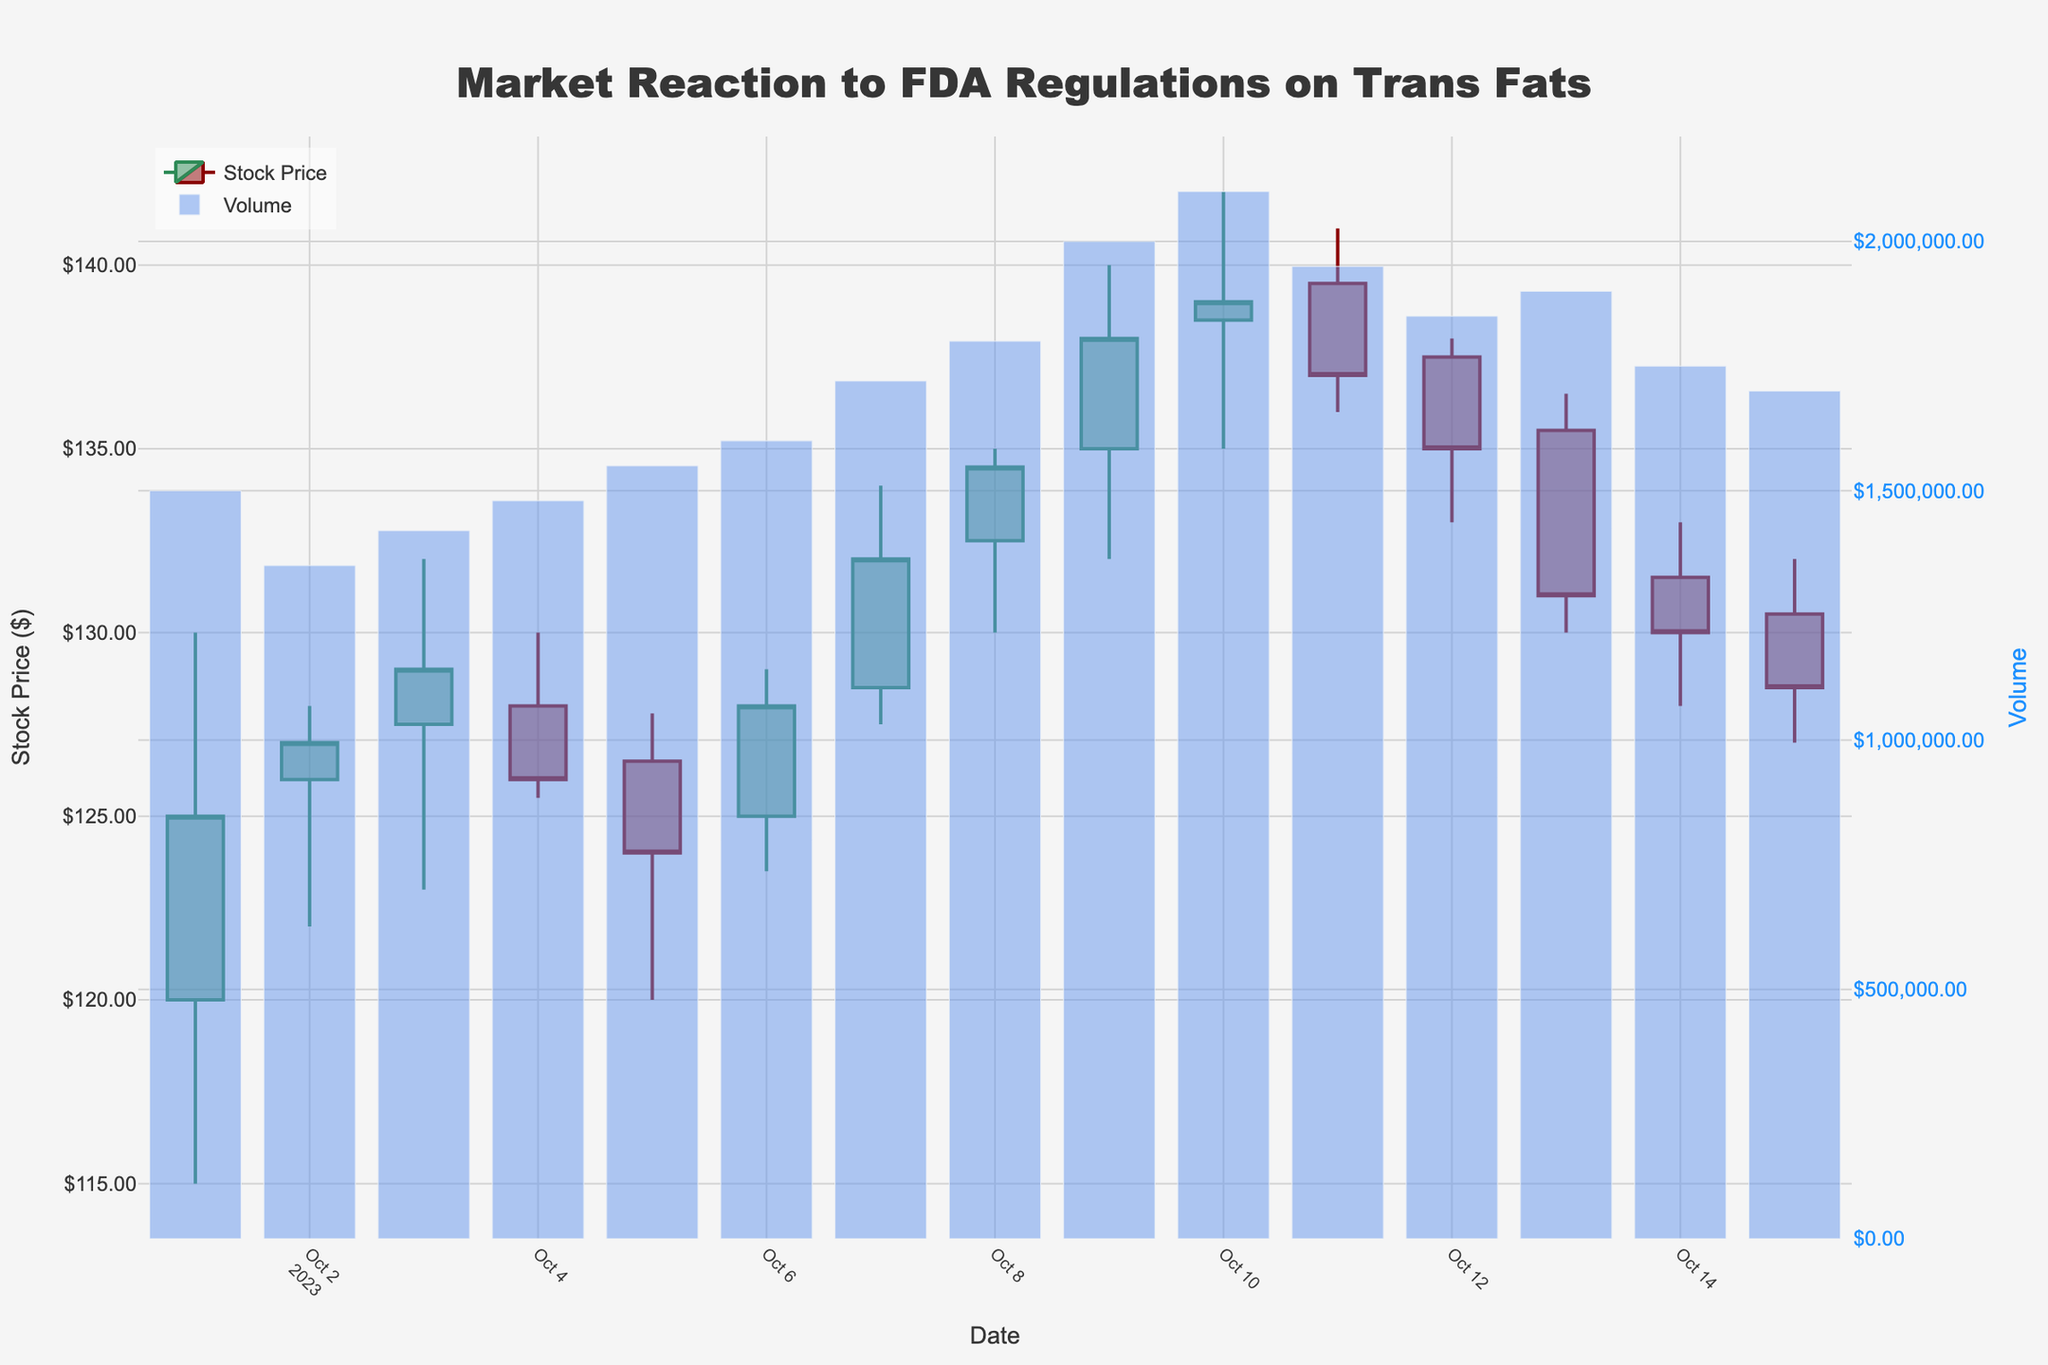What is the highest stock price during the period shown in the figure? The highest stock price is found by looking at the highest points on the candlestick wicks. These wicks represent the 'High' price for each day. The highest price is observed on October 10, 2023, when the price reached $142.00.
Answer: $142.00 What was the closing price on October 1, 2023? To find the closing price on a specific date, look at the bottom of the body of the candlestick for that date. On October 1, 2023, the closing price is $125.00 as indicated by the bottom of the green candlestick body (since it was an increasing day).
Answer: $125.00 How did the stock price change from October 13 to October 14, 2023? To determine the price change, subtract the closing price on October 13 from the closing price on October 14. The closing price on October 13 was $131.00, and on October 14 it was $130.00, indicating a drop of $1.00.
Answer: -$1.00 What is the average closing price over the entire period shown? The average closing price is calculated by summing all the closing prices and then dividing by the number of days. Sum of closing prices: (125 + 127 + 129 + 126 + 124 + 128 + 132 + 134.5 + 138 + 139 + 137 + 135 + 131 + 130 + 128.5 = 1924), divided by 15 days.
Answer: $128.27 Which day had the highest trading volume, and what was it? The highest trading volume is represented by the tallest bar in the volume bar chart (right y-axis). October 10, 2023, has the highest trading volume of 2,100,000.
Answer: October 10, 2023, 2,100,000 How many days showed an increasing price trend compared to the previous day? Count the number of green candlesticks, as they represent days where the closing price was higher than the opening price. There are 10 days with green candlesticks, indicating an increasing price trend.
Answer: 10 days Compare the opening price on October 1, 2023, with the opening price on October 15, 2023. Which is higher? The opening price on October 1, 2023, was $120.00, while the opening price on October 15, 2023, was $130.50. Therefore, the opening price on October 15 is higher.
Answer: October 15, 2023 What was the market reaction in terms of price trend immediately following the new FDA regulations announcement? To identify the market reaction, observe the trend in closing prices immediately around the date likely associated with the FDA announcement. The prices started increasing significantly from October 6, peaking at October 10 before slightly correcting in the following days.
Answer: Increased initially, then corrected 